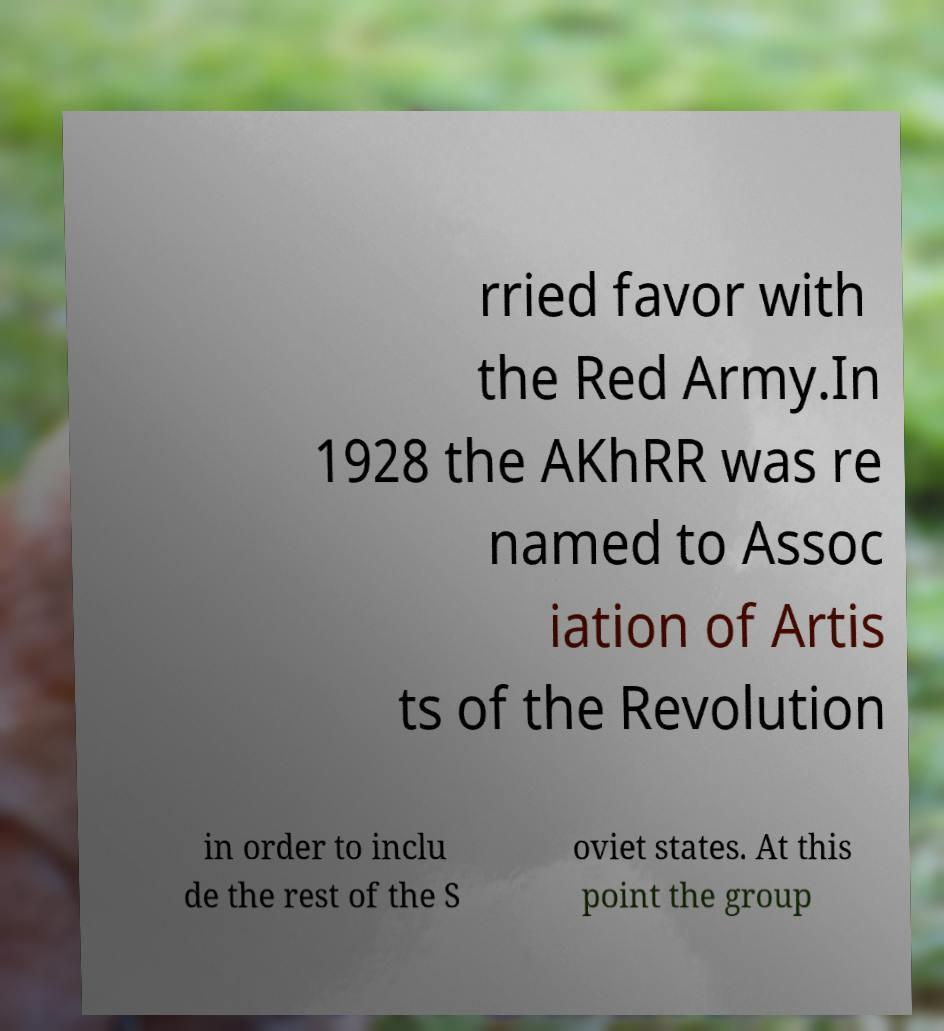Please read and relay the text visible in this image. What does it say? rried favor with the Red Army.In 1928 the AKhRR was re named to Assoc iation of Artis ts of the Revolution in order to inclu de the rest of the S oviet states. At this point the group 